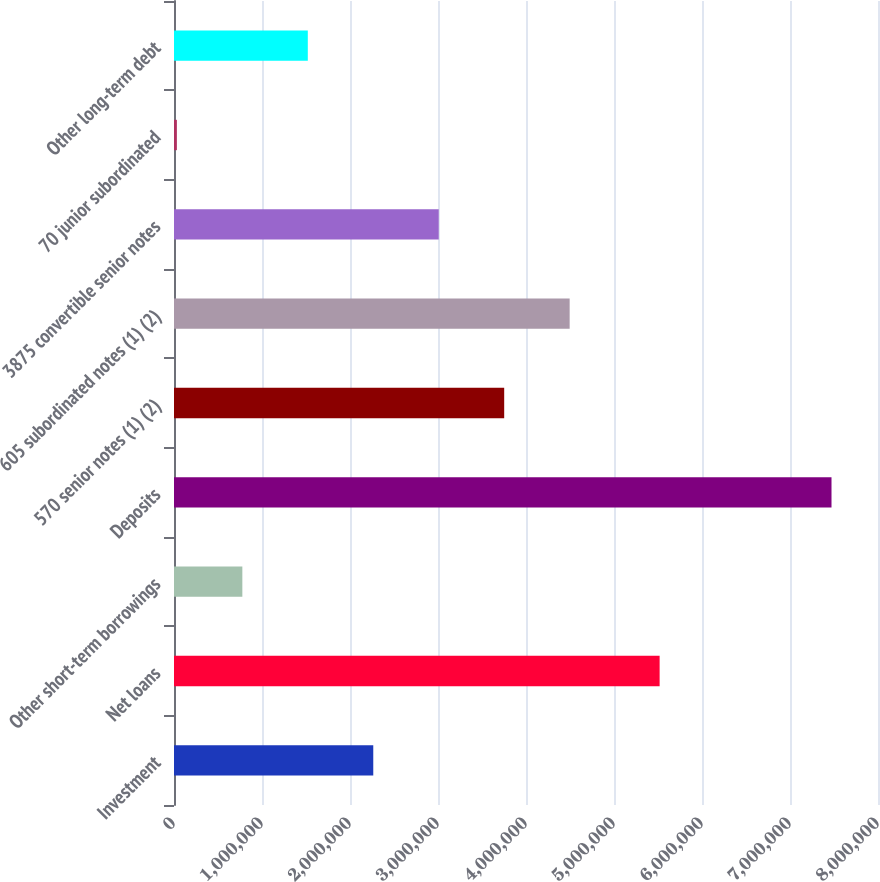<chart> <loc_0><loc_0><loc_500><loc_500><bar_chart><fcel>Investment<fcel>Net loans<fcel>Other short-term borrowings<fcel>Deposits<fcel>570 senior notes (1) (2)<fcel>605 subordinated notes (1) (2)<fcel>3875 convertible senior notes<fcel>70 junior subordinated<fcel>Other long-term debt<nl><fcel>2.26441e+06<fcel>5.51843e+06<fcel>776634<fcel>7.47161e+06<fcel>3.75218e+06<fcel>4.49607e+06<fcel>3.00829e+06<fcel>32747<fcel>1.52052e+06<nl></chart> 